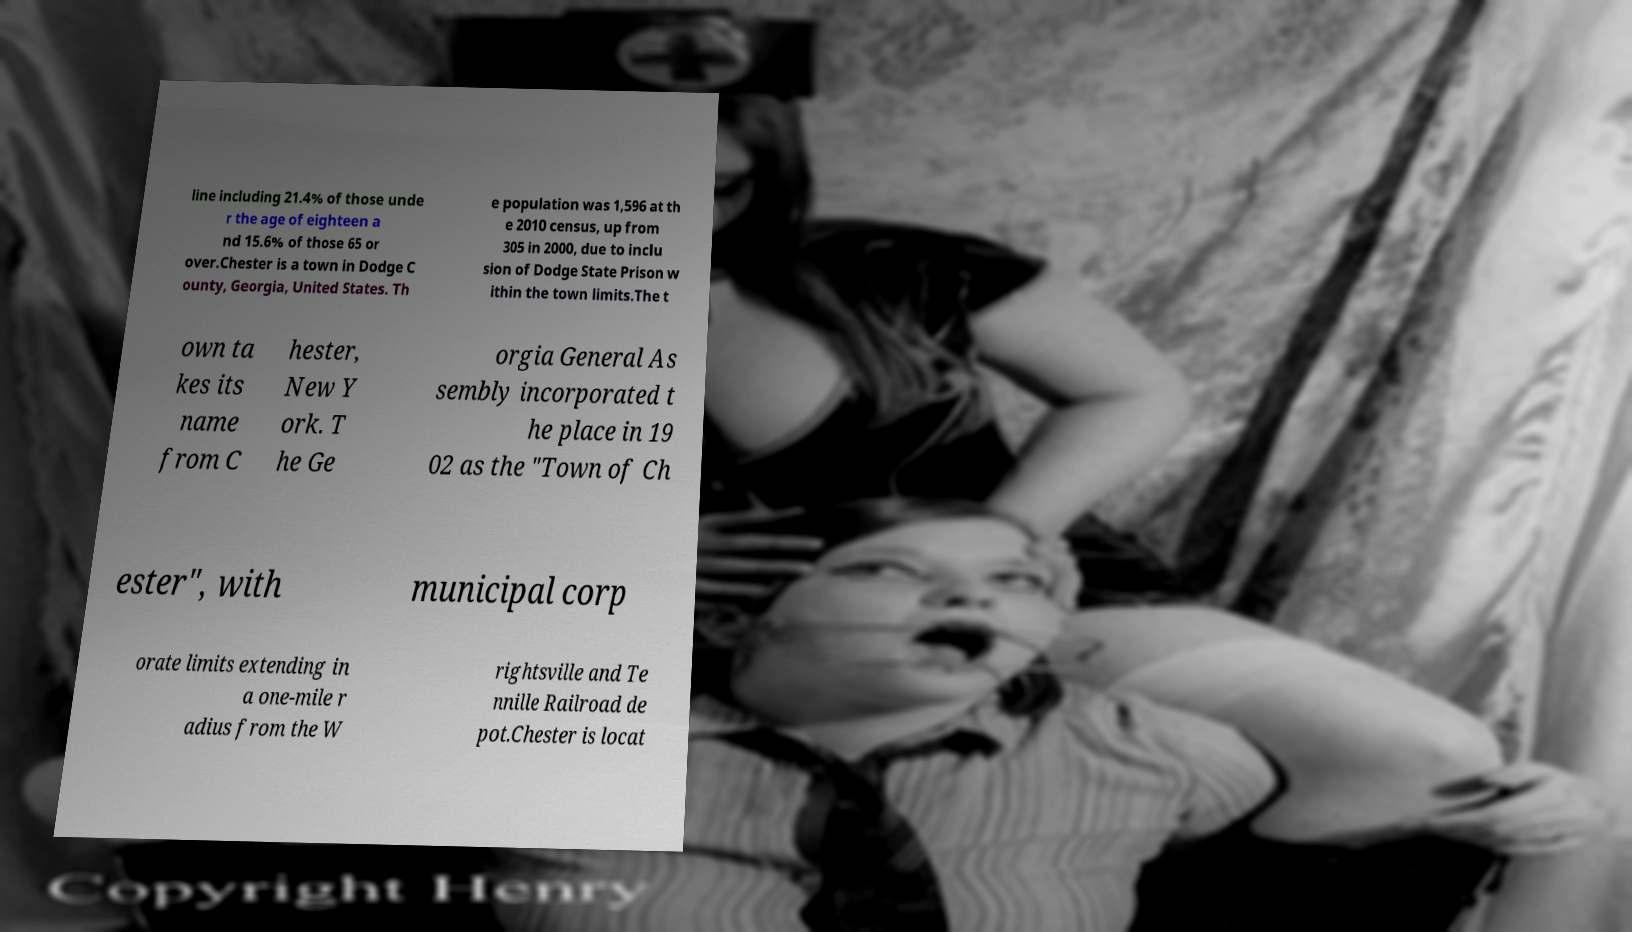For documentation purposes, I need the text within this image transcribed. Could you provide that? line including 21.4% of those unde r the age of eighteen a nd 15.6% of those 65 or over.Chester is a town in Dodge C ounty, Georgia, United States. Th e population was 1,596 at th e 2010 census, up from 305 in 2000, due to inclu sion of Dodge State Prison w ithin the town limits.The t own ta kes its name from C hester, New Y ork. T he Ge orgia General As sembly incorporated t he place in 19 02 as the "Town of Ch ester", with municipal corp orate limits extending in a one-mile r adius from the W rightsville and Te nnille Railroad de pot.Chester is locat 